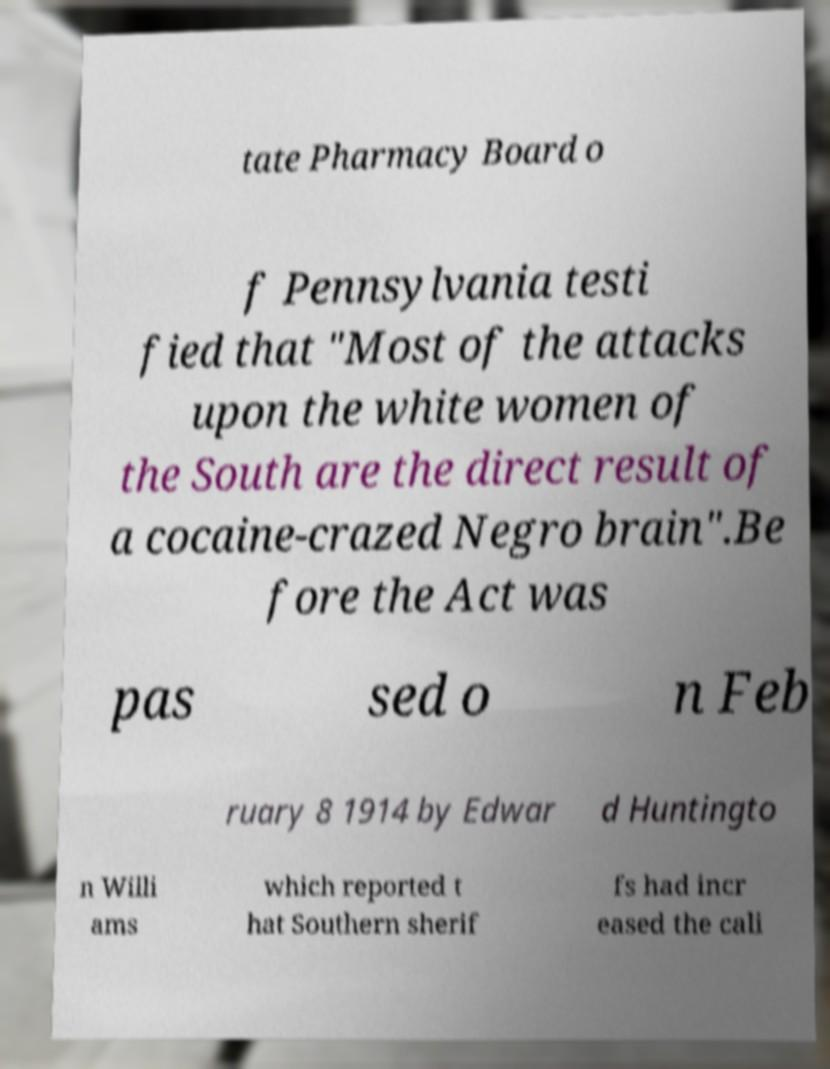Could you extract and type out the text from this image? tate Pharmacy Board o f Pennsylvania testi fied that "Most of the attacks upon the white women of the South are the direct result of a cocaine-crazed Negro brain".Be fore the Act was pas sed o n Feb ruary 8 1914 by Edwar d Huntingto n Willi ams which reported t hat Southern sherif fs had incr eased the cali 